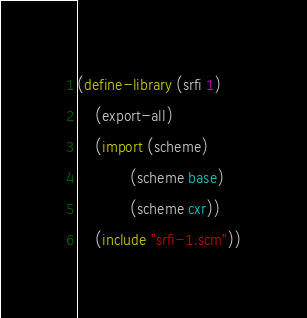<code> <loc_0><loc_0><loc_500><loc_500><_Scheme_>(define-library (srfi 1)
    (export-all)
    (import (scheme)
            (scheme base) 
            (scheme cxr))
    (include "srfi-1.scm"))
</code> 